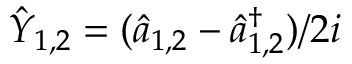Convert formula to latex. <formula><loc_0><loc_0><loc_500><loc_500>\hat { Y } _ { 1 , 2 } = ( \hat { a } _ { 1 , 2 } - \hat { a } _ { 1 , 2 } ^ { \dagger } ) / 2 i</formula> 